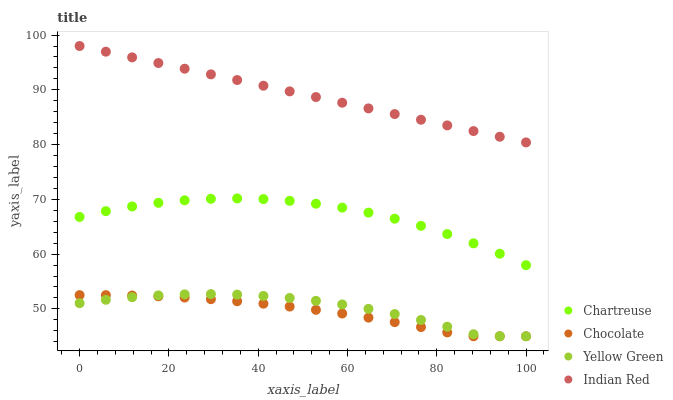Does Chocolate have the minimum area under the curve?
Answer yes or no. Yes. Does Indian Red have the maximum area under the curve?
Answer yes or no. Yes. Does Yellow Green have the minimum area under the curve?
Answer yes or no. No. Does Yellow Green have the maximum area under the curve?
Answer yes or no. No. Is Indian Red the smoothest?
Answer yes or no. Yes. Is Yellow Green the roughest?
Answer yes or no. Yes. Is Yellow Green the smoothest?
Answer yes or no. No. Is Indian Red the roughest?
Answer yes or no. No. Does Yellow Green have the lowest value?
Answer yes or no. Yes. Does Indian Red have the lowest value?
Answer yes or no. No. Does Indian Red have the highest value?
Answer yes or no. Yes. Does Yellow Green have the highest value?
Answer yes or no. No. Is Yellow Green less than Chartreuse?
Answer yes or no. Yes. Is Indian Red greater than Chartreuse?
Answer yes or no. Yes. Does Yellow Green intersect Chocolate?
Answer yes or no. Yes. Is Yellow Green less than Chocolate?
Answer yes or no. No. Is Yellow Green greater than Chocolate?
Answer yes or no. No. Does Yellow Green intersect Chartreuse?
Answer yes or no. No. 